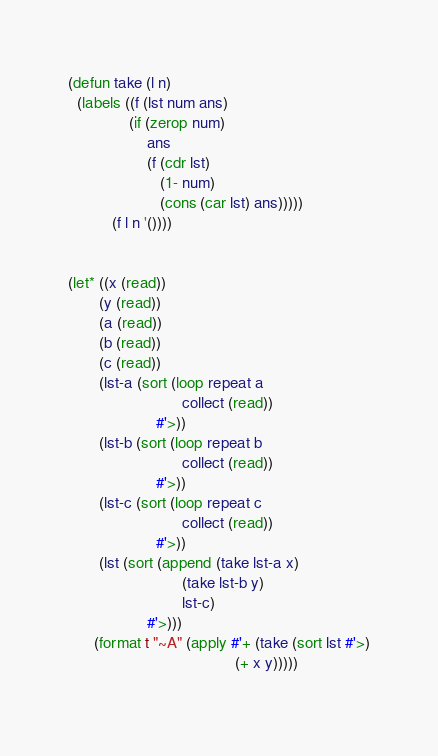<code> <loc_0><loc_0><loc_500><loc_500><_Lisp_>(defun take (l n)
  (labels ((f (lst num ans)
              (if (zerop num)
                  ans
                  (f (cdr lst)
                     (1- num)
                     (cons (car lst) ans)))))
          (f l n '())))
      

(let* ((x (read))
       (y (read))
       (a (read))
       (b (read))
       (c (read))
       (lst-a (sort (loop repeat a
                          collect (read))
                    #'>))
       (lst-b (sort (loop repeat b
                          collect (read))
                    #'>))
       (lst-c (sort (loop repeat c
                          collect (read))
                    #'>))
       (lst (sort (append (take lst-a x)
                          (take lst-b y)
                          lst-c)
                  #'>)))
      (format t "~A" (apply #'+ (take (sort lst #'>)
                                      (+ x y)))))
      </code> 